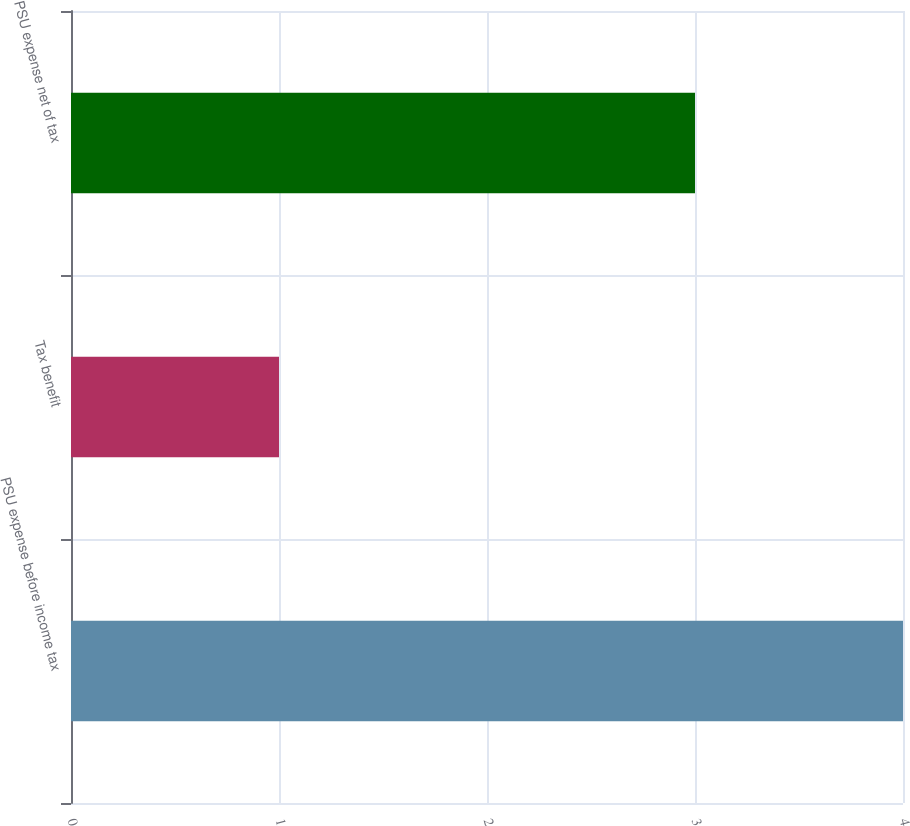<chart> <loc_0><loc_0><loc_500><loc_500><bar_chart><fcel>PSU expense before income tax<fcel>Tax benefit<fcel>PSU expense net of tax<nl><fcel>4<fcel>1<fcel>3<nl></chart> 